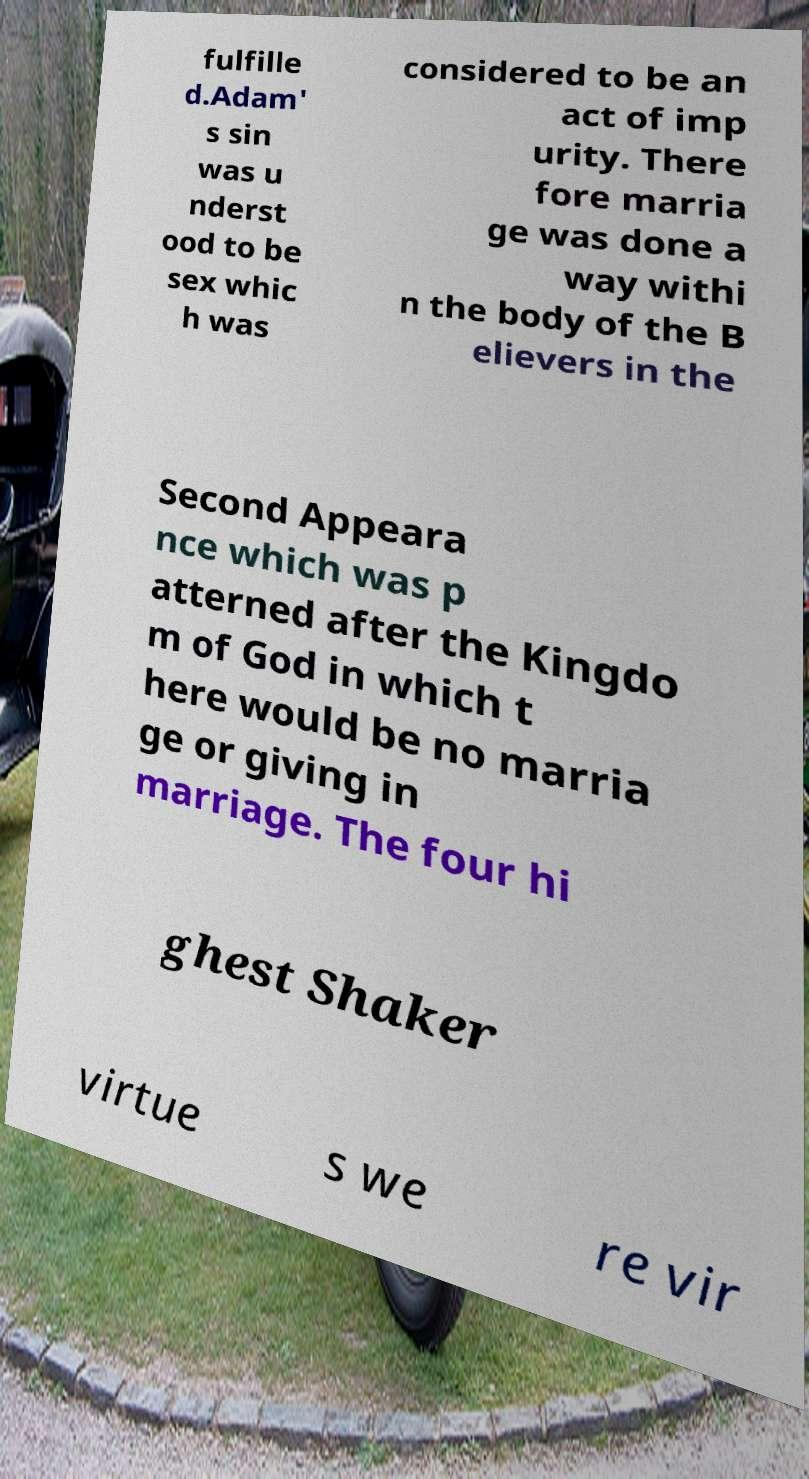I need the written content from this picture converted into text. Can you do that? fulfille d.Adam' s sin was u nderst ood to be sex whic h was considered to be an act of imp urity. There fore marria ge was done a way withi n the body of the B elievers in the Second Appeara nce which was p atterned after the Kingdo m of God in which t here would be no marria ge or giving in marriage. The four hi ghest Shaker virtue s we re vir 